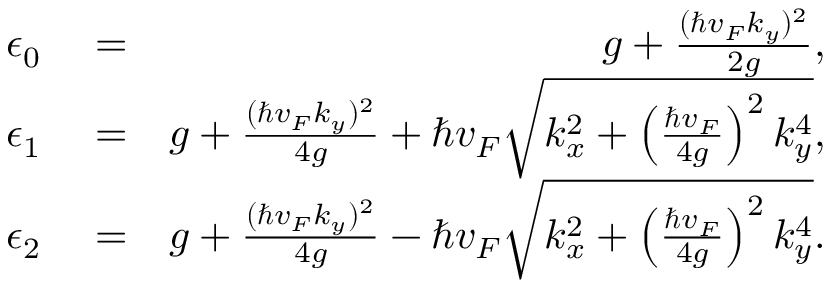<formula> <loc_0><loc_0><loc_500><loc_500>\begin{array} { r l r } { \epsilon _ { 0 } } & = } & { g + \frac { ( \hbar { v } _ { F } k _ { y } ) ^ { 2 } } { 2 g } , } \\ { \epsilon _ { 1 } } & = } & { g + \frac { ( \hbar { v } _ { F } k _ { y } ) ^ { 2 } } { 4 g } + \hbar { v } _ { F } \sqrt { k _ { x } ^ { 2 } + \left ( \frac { \hbar { v } _ { F } } { 4 g } \right ) ^ { 2 } k _ { y } ^ { 4 } } , } \\ { \epsilon _ { 2 } } & = } & { g + \frac { ( \hbar { v } _ { F } k _ { y } ) ^ { 2 } } { 4 g } - \hbar { v } _ { F } \sqrt { k _ { x } ^ { 2 } + \left ( \frac { \hbar { v } _ { F } } { 4 g } \right ) ^ { 2 } k _ { y } ^ { 4 } } . } \end{array}</formula> 